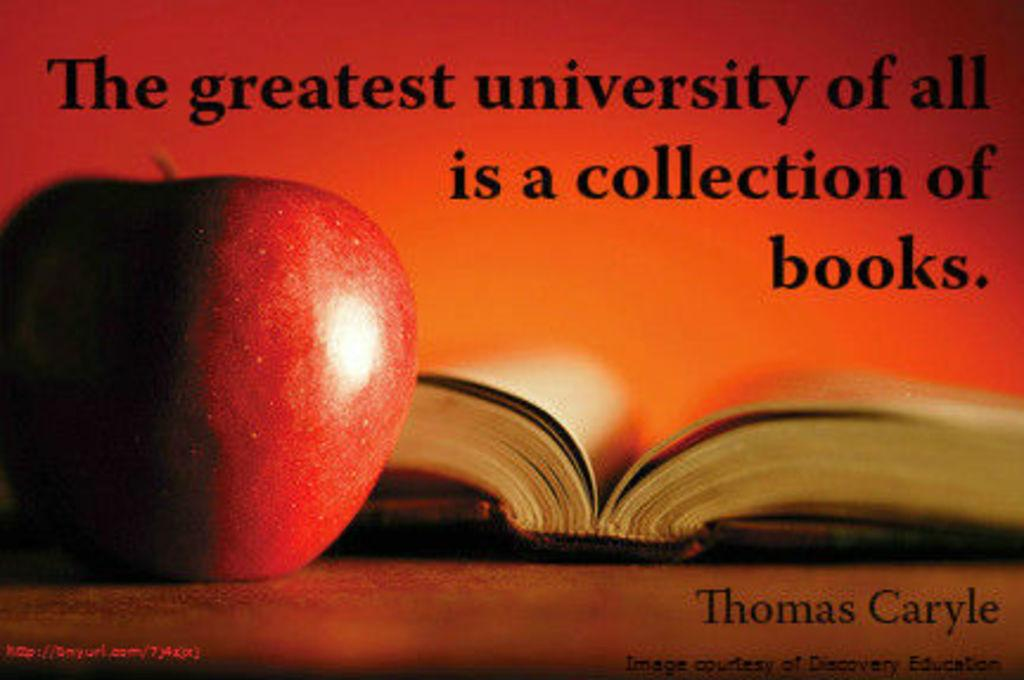<image>
Provide a brief description of the given image. An apple is in front of an open book with the words "The greatest university of all is a collection of books." above them. 